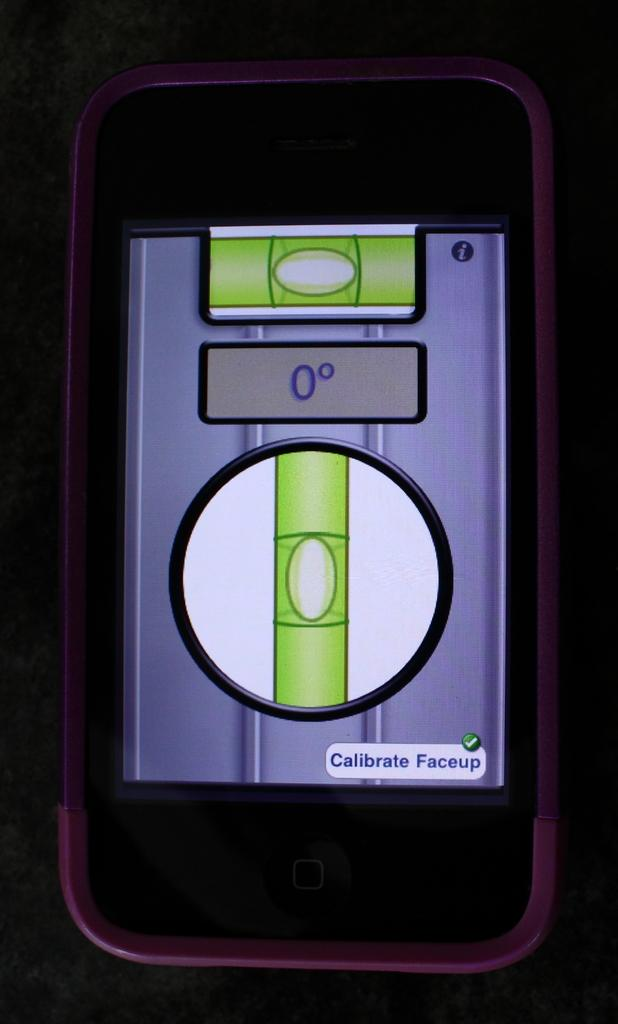Provide a one-sentence caption for the provided image. A phone with a pink case is calibrating a faceup, and reading at zero degrees. 